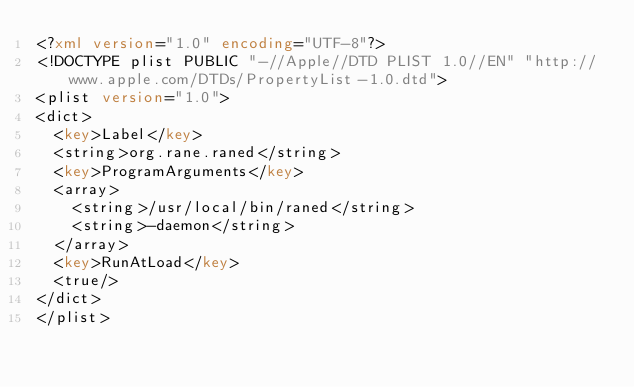Convert code to text. <code><loc_0><loc_0><loc_500><loc_500><_XML_><?xml version="1.0" encoding="UTF-8"?>
<!DOCTYPE plist PUBLIC "-//Apple//DTD PLIST 1.0//EN" "http://www.apple.com/DTDs/PropertyList-1.0.dtd">
<plist version="1.0">
<dict>
	<key>Label</key>
	<string>org.rane.raned</string>
	<key>ProgramArguments</key>
	<array>
		<string>/usr/local/bin/raned</string>
		<string>-daemon</string>
	</array>
	<key>RunAtLoad</key>
	<true/>
</dict>
</plist>
</code> 